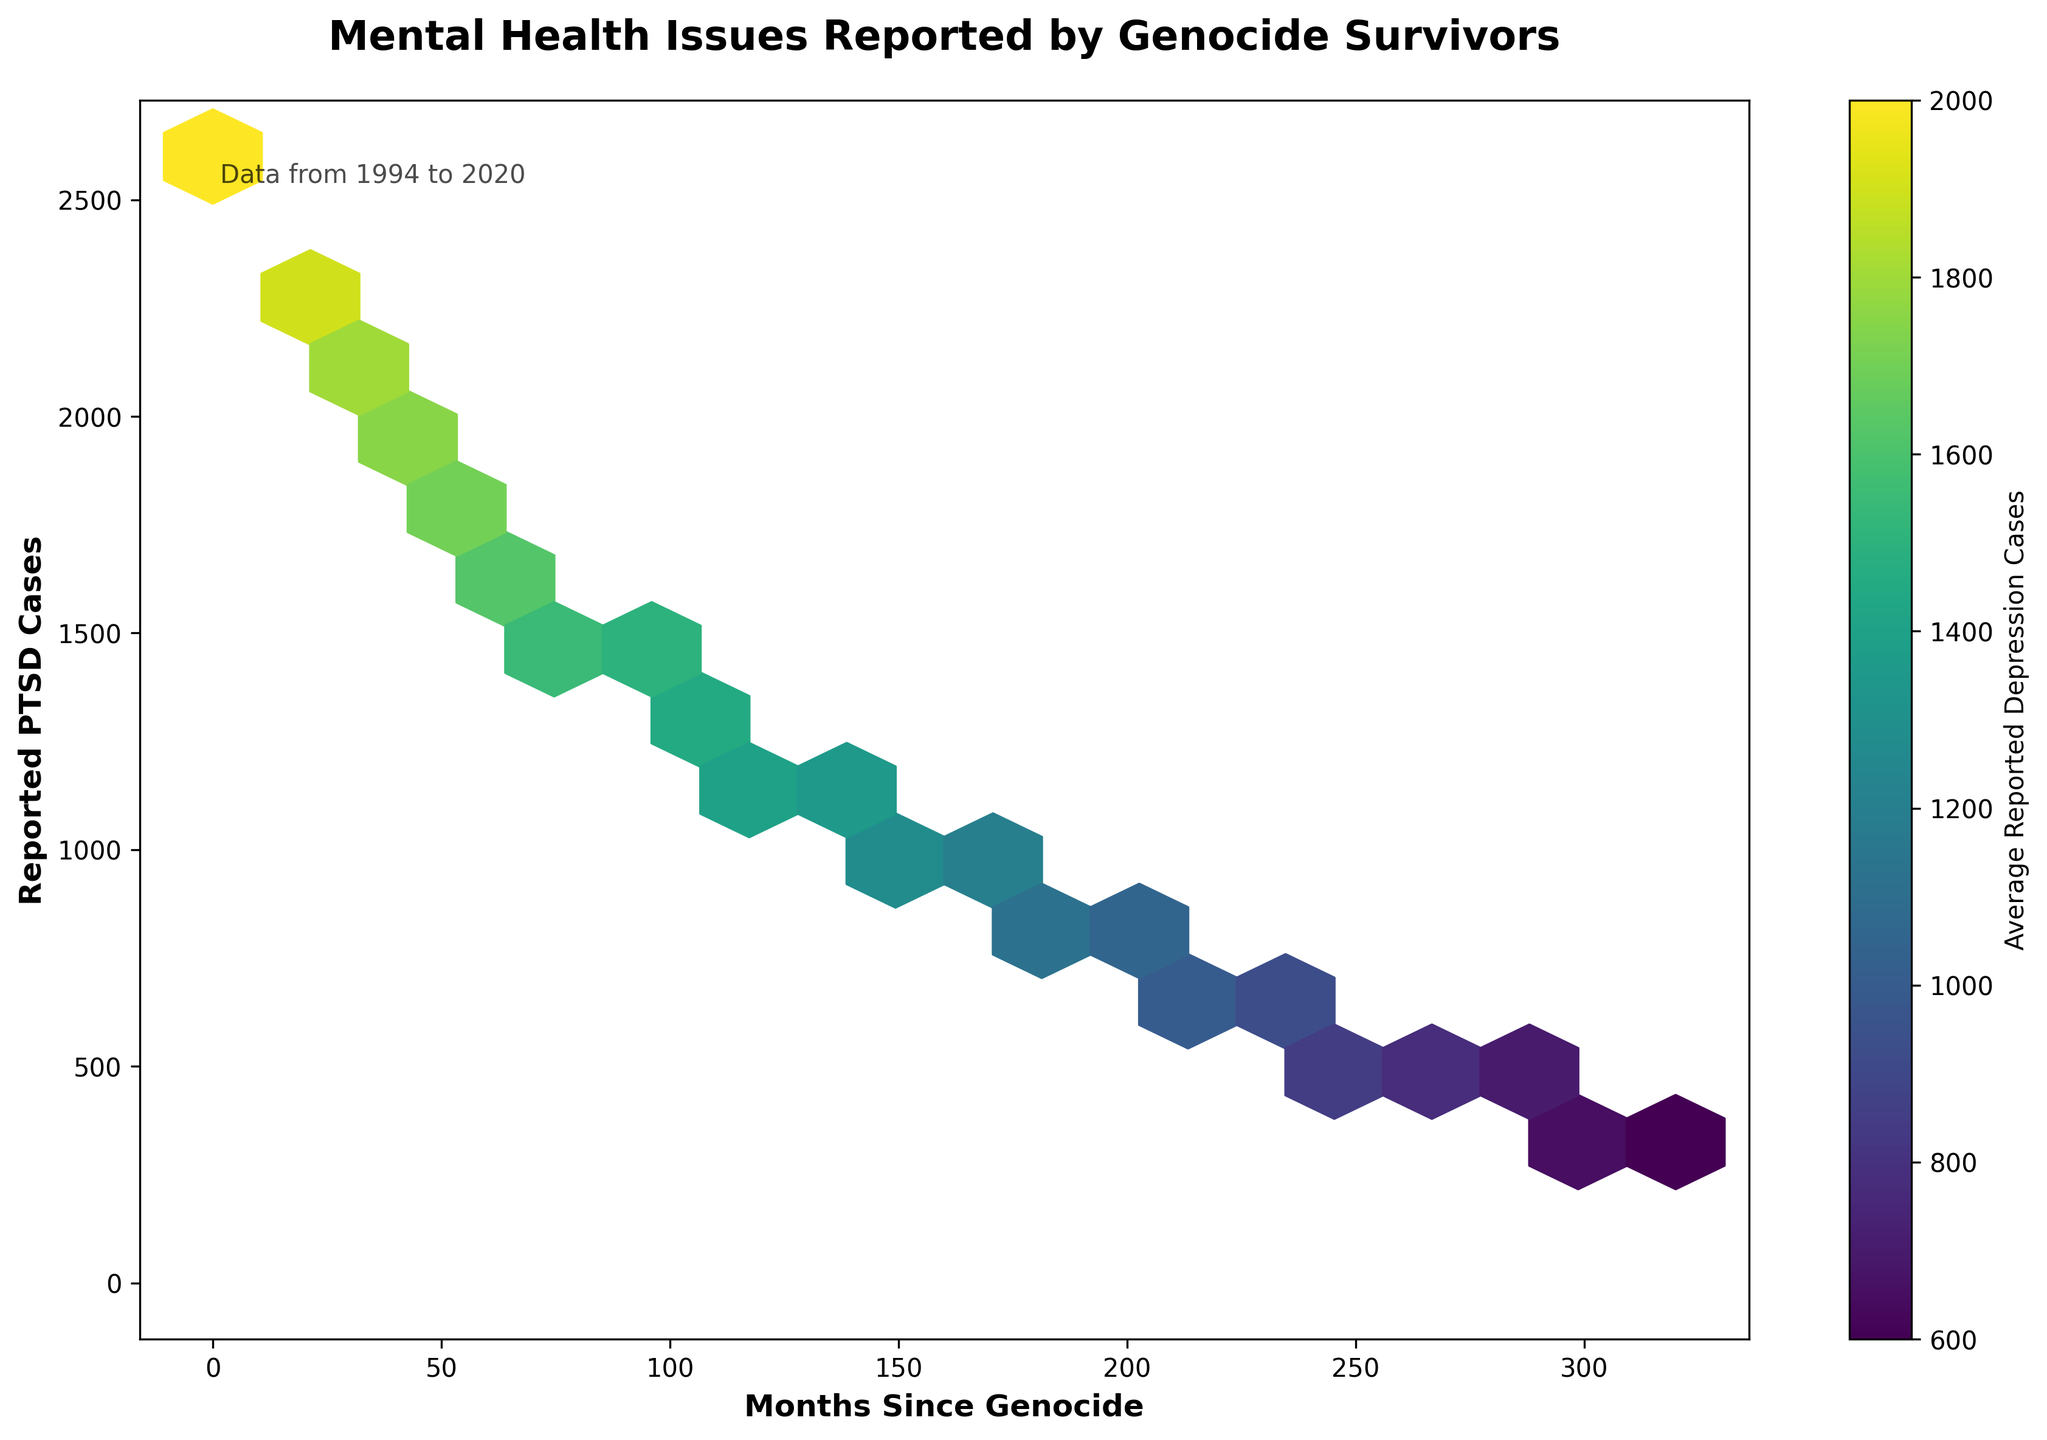What's the title of the figure? The title of the figure is usually found at the top, describing what the plot is about. In this case, it is "Mental Health Issues Reported by Genocide Survivors".
Answer: Mental Health Issues Reported by Genocide Survivors What do the axes represent? The labels on the horizontal and vertical axes should indicate what each axis represents. The horizontal axis is labeled "Months Since Genocide," and the vertical axis is labeled "Reported PTSD Cases".
Answer: Months Since Genocide and Reported PTSD Cases What does the color indicate in the hexbin plot? The color gradient in a hexbin plot is tied to a third variable. The color in this plot represents the average number of Reported Depression Cases, as indicated by the color bar on the right side of the plot. The darker the color, the higher the average number of reported depression cases.
Answer: Average Reported Depression Cases In which interval of months since the genocide do we see the highest concentration of reported PTSD cases? By examining the density of the hexagons, we can see that the highest concentration of hexagons occurs at the lower end of the "Months Since Genocide" axis, between 0 and 60 months.
Answer: 0 to 60 months How do reported PTSD cases change over time? We can observe the trend by looking at the vertical spread of hexagons along the horizontal axis. The reported PTSD cases generally decrease over time, indicated by a downward slope from left to right.
Answer: Decrease over time Around 120 months after the genocide, what is the average number of reported depression cases? Identify the hexagons around 120 on the horizontal axis and check their color against the color bar. The color indicates the approximate average reported depression cases within that time frame.
Answer: Around 1400 Compare the number of reported PTSD cases at 0 months and 312 months after the genocide. By looking at the vertical positions of the hexagons at x=0 and x=312, we see that the PTSD cases start around 2500 at 0 months and drop to about 300 at 312 months.
Answer: 2500 at 0 months, 300 at 312 months Which has a steeper decline: reported PTSD cases or reported depression cases over time? Analyze the overall slopes of the hexagons and color gradients over time. The visual data show a steeper and more consistent decline in reported PTSD cases compared to the average depression cases.
Answer: Reported PTSD cases At which point do PTSD and depression cases become roughly equal in number over time? Look for intersections where the vertical position (PTSD cases) nearly matches the color bar value (depression cases). Around 200 to 250 months, these cases appear closer in number.
Answer: Around 200 to 250 months What is the trend of average reported depression cases over decades since the genocide? Observing the color gradient from left (0 months) to right (312 months), we notice that the average reported depression cases also show a downward trend but at a different rate compared to PTSD cases.
Answer: Decreasing trend 